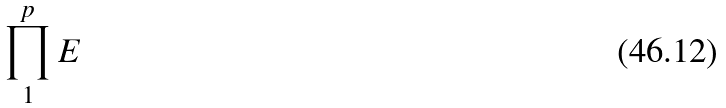<formula> <loc_0><loc_0><loc_500><loc_500>\prod _ { 1 } ^ { p } E</formula> 